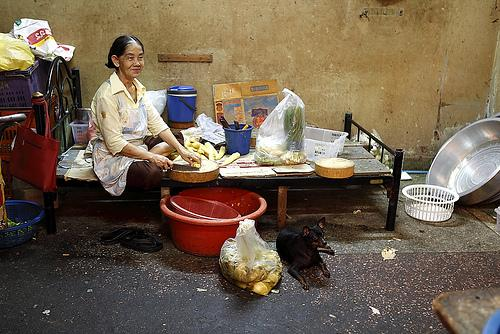Question: why can we assume she is happy?
Choices:
A. She's laughing.
B. She's cheering.
C. She's smiling.
D. She's getting married.
Answer with the letter. Answer: C Question: how many dogs?
Choices:
A. One.
B. Two.
C. Three.
D. Four.
Answer with the letter. Answer: A Question: what is she holding?
Choices:
A. A gun.
B. A fork.
C. A sword.
D. Knife.
Answer with the letter. Answer: D Question: what animal is laying on the ground?
Choices:
A. Cat.
B. Goat.
C. Moose.
D. Dog.
Answer with the letter. Answer: D Question: who is in the picture?
Choices:
A. Two sisters.
B. A boy.
C. A man.
D. A woman.
Answer with the letter. Answer: D 